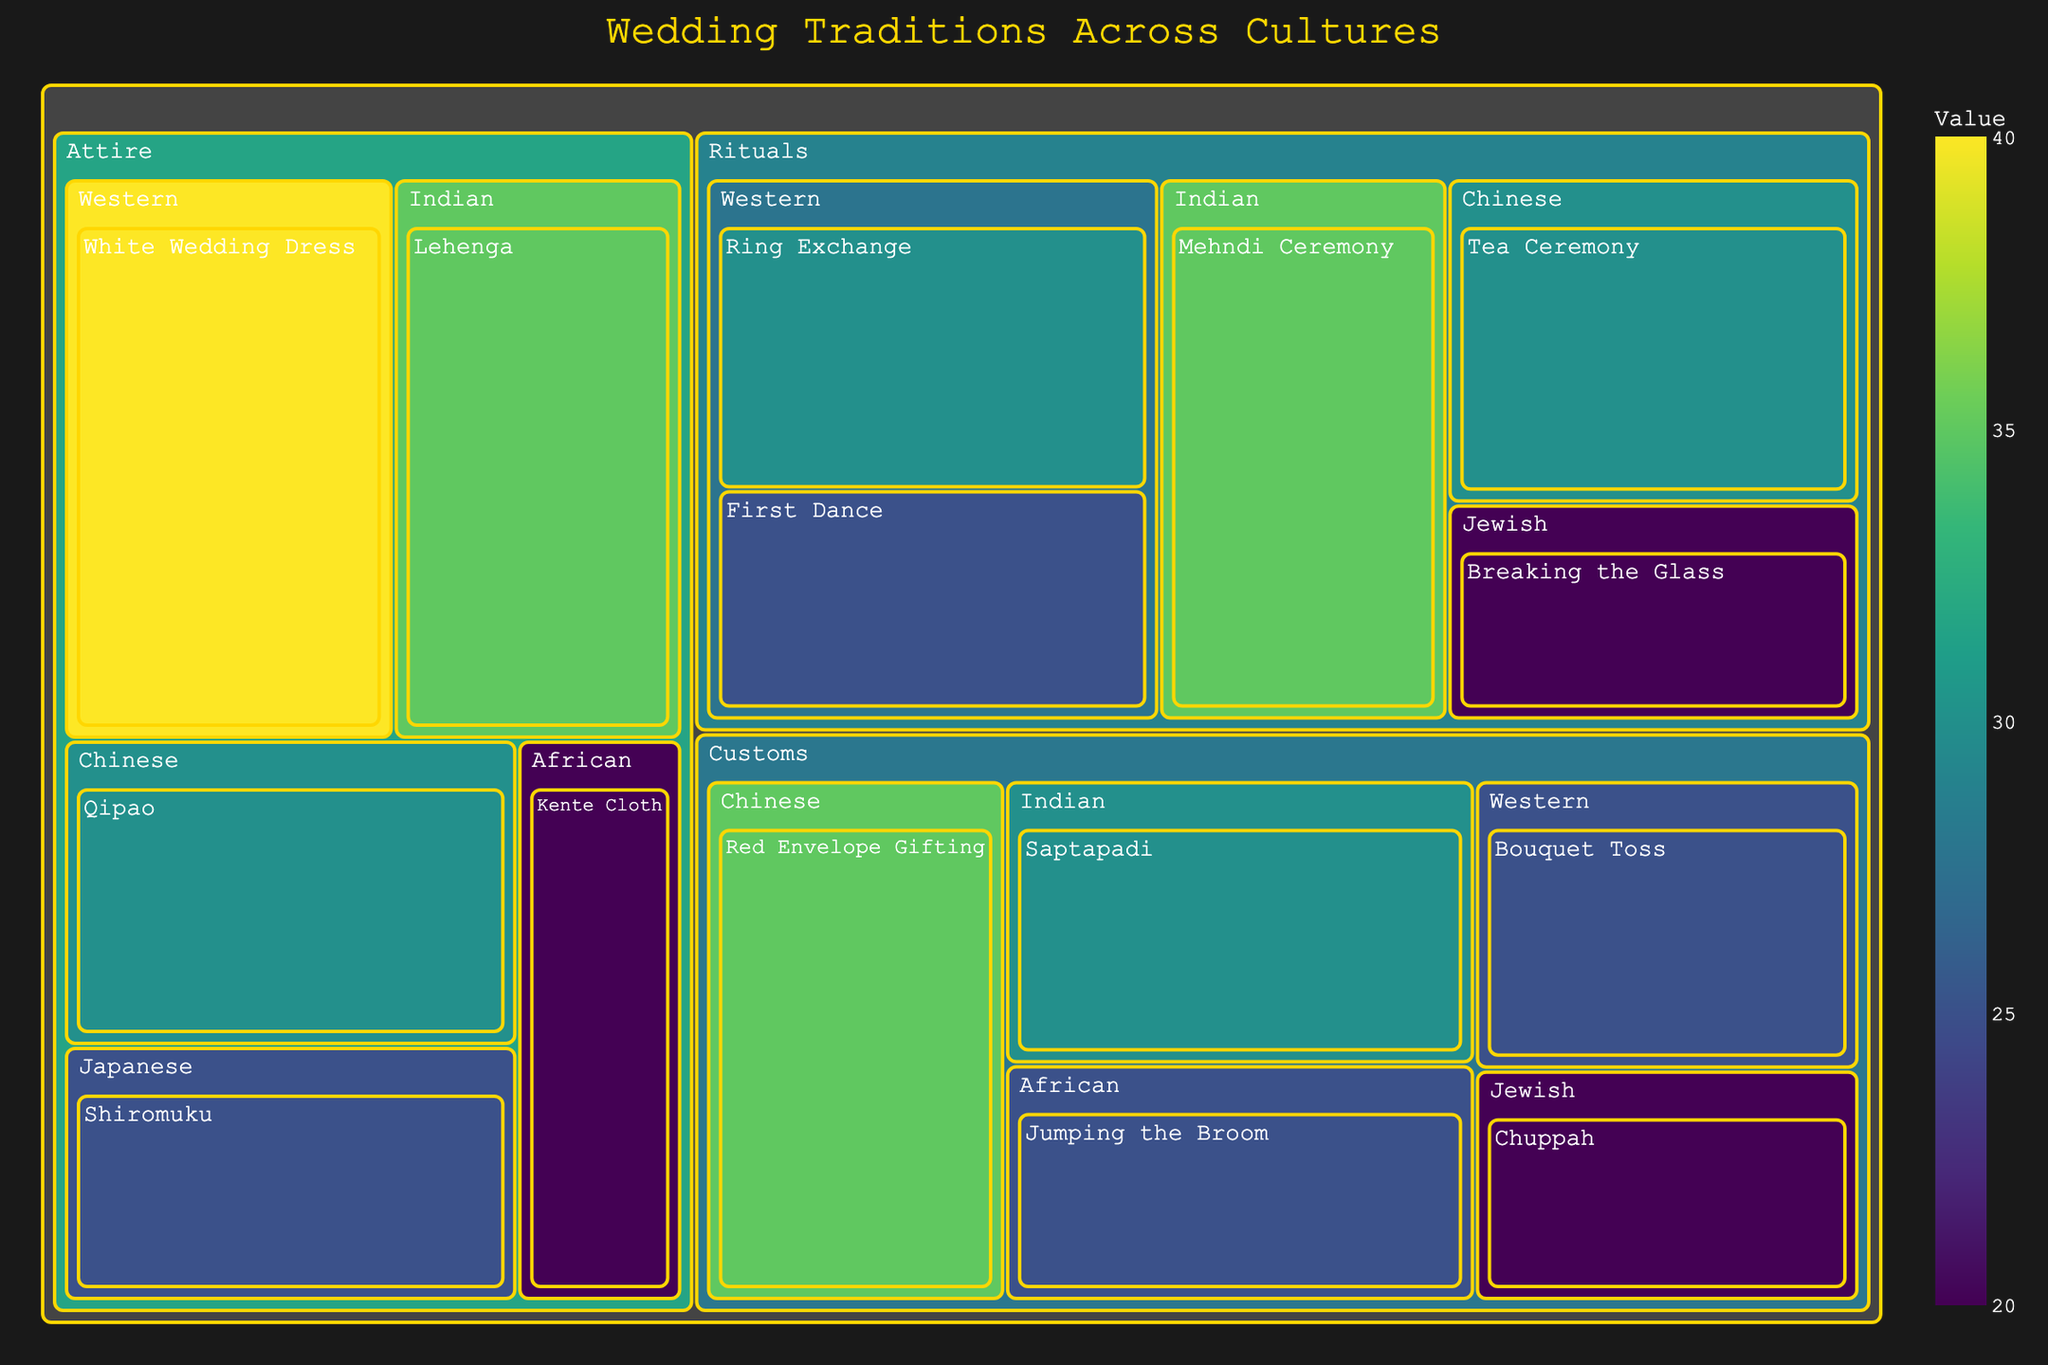What's the title of the figure? The title is usually displayed at the top of the figure. It indicates the main topic or purpose of the figure.
Answer: Wedding Traditions Across Cultures Which tradition has the highest value within the 'Rituals' category? By looking at the 'Rituals' section, the value for each tradition is shown. The 'Mehndi Ceremony' has the highest value of 35.
Answer: Mehndi Ceremony What is the total value of the 'Attire' category? Sum the values of each subcategory within 'Attire'. The values are 40, 35, 30, 25, and 20. Adding them up: 40 + 35 + 30 + 25 + 20 = 150.
Answer: 150 Which culture has the tradition 'Bouquet Toss'? The tradition 'Bouquet Toss' is listed under the 'Western' subcategory in the 'Customs' category.
Answer: Western How does the value of 'Breaking the Glass' compare to 'First Dance'? Look at 'Breaking the Glass' in 'Rituals' with a value of 20 and 'First Dance' with a value of 25. The value of 'First Dance' is higher.
Answer: First Dance has a higher value What is the average value of all traditions in the 'Customs' category? Sum the values of all traditions in 'Customs': 25, 30, 35, 20, and 25. Total = 135. Divide by the number of traditions (5): 135/5 = 27.
Answer: 27 Which category has the tradition 'Chuppah'? The 'Chuppah' tradition can be found under the 'Customs' category in the 'Jewish' subcategory.
Answer: Customs What's the difference in value between 'Jumping the Broom' and 'White Wedding Dress'? 'Jumping the Broom' has a value of 25, and 'White Wedding Dress' has a value of 40. The difference is 40 - 25 = 15.
Answer: 15 Which 'Attire' subcategory tradition has the lowest value? In the 'Attire' category, 'Kente Cloth' has the lowest value, which is 20.
Answer: Kente Cloth How many traditions are there in total in the 'Rituals' category? Count the number of individual traditions listed under 'Rituals'. There are 5 traditions: Ring Exchange, First Dance, Mehndi Ceremony, Tea Ceremony, and Breaking the Glass.
Answer: 5 